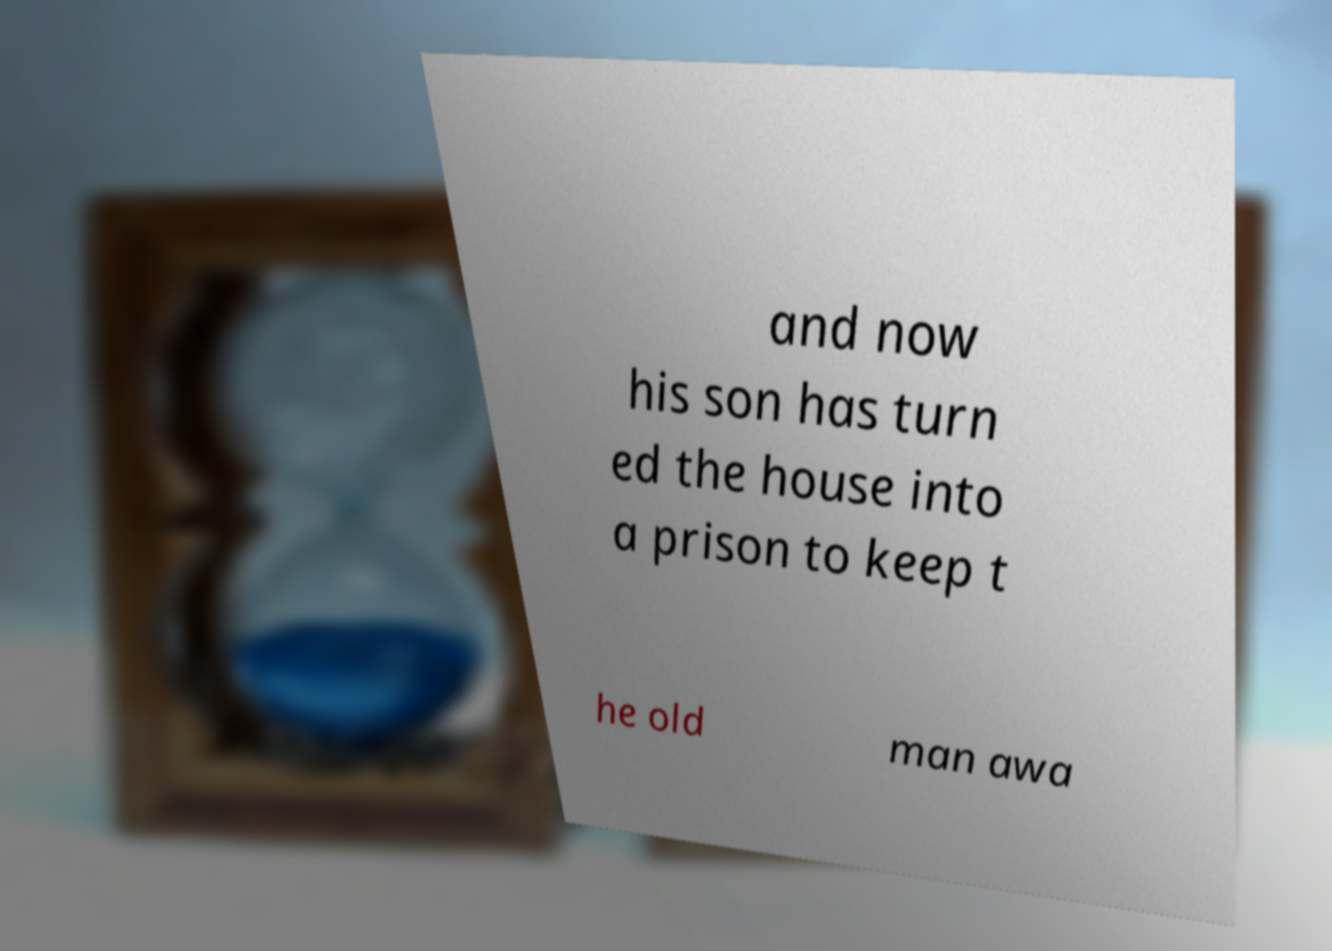Please identify and transcribe the text found in this image. and now his son has turn ed the house into a prison to keep t he old man awa 